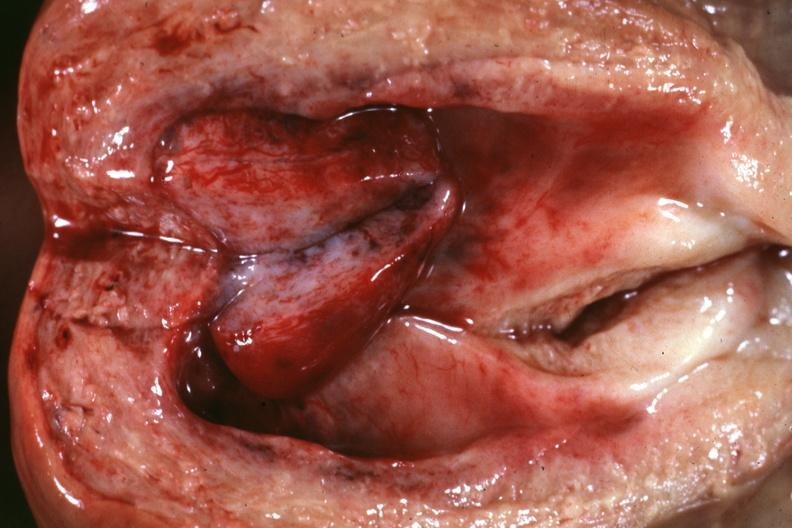s female reproductive present?
Answer the question using a single word or phrase. Yes 